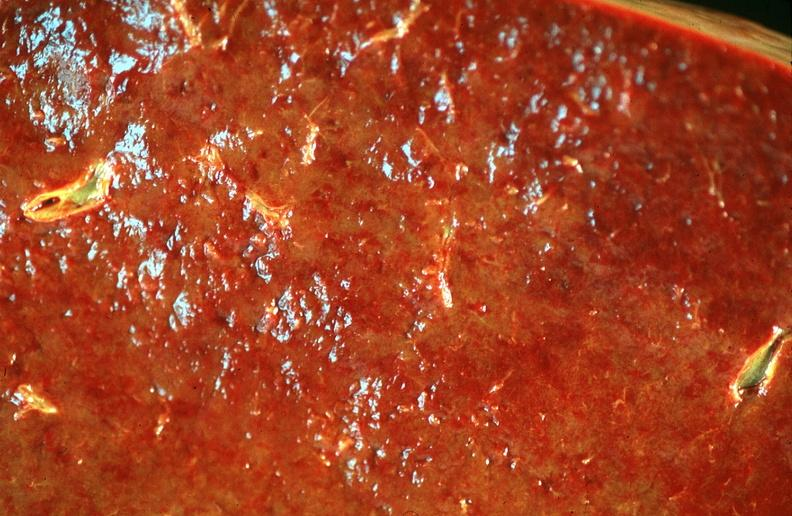why does this image show spleen, chronic congestion?
Answer the question using a single word or phrase. Due to portal hypertension from cirrhosis hcv 